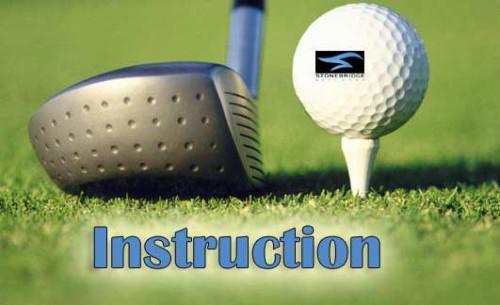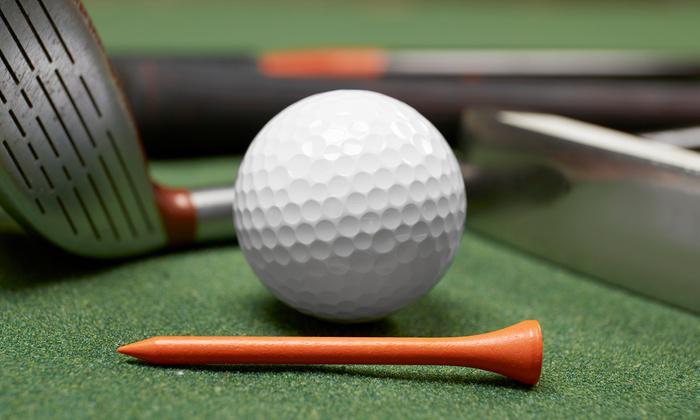The first image is the image on the left, the second image is the image on the right. For the images displayed, is the sentence "The right image shows one man standing and holding a golf club next to a man crouched down beside him on a golf course" factually correct? Answer yes or no. No. The first image is the image on the left, the second image is the image on the right. Given the left and right images, does the statement "A man crouches in the grass to the right of a man who is standing and swinging a golf club." hold true? Answer yes or no. No. 